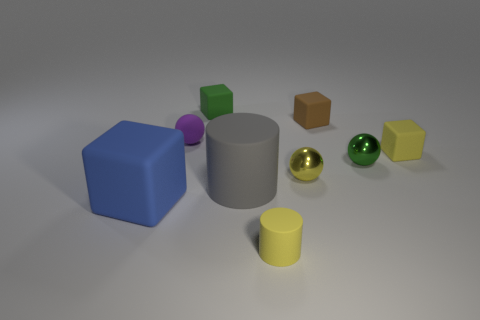Subtract all tiny yellow balls. How many balls are left? 2 Subtract all cylinders. How many objects are left? 7 Add 1 yellow matte things. How many objects exist? 10 Subtract 1 balls. How many balls are left? 2 Add 9 small yellow shiny spheres. How many small yellow shiny spheres are left? 10 Add 9 yellow balls. How many yellow balls exist? 10 Subtract all green balls. How many balls are left? 2 Subtract 1 brown cubes. How many objects are left? 8 Subtract all cyan cubes. Subtract all red spheres. How many cubes are left? 4 Subtract all yellow balls. How many blue cubes are left? 1 